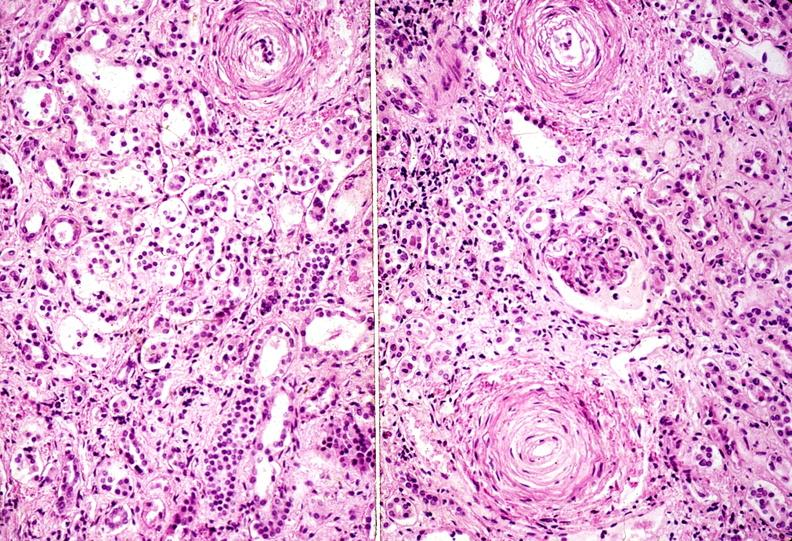does this image show kidney, arteriolonephrosclerosis, malignant hypertension?
Answer the question using a single word or phrase. Yes 